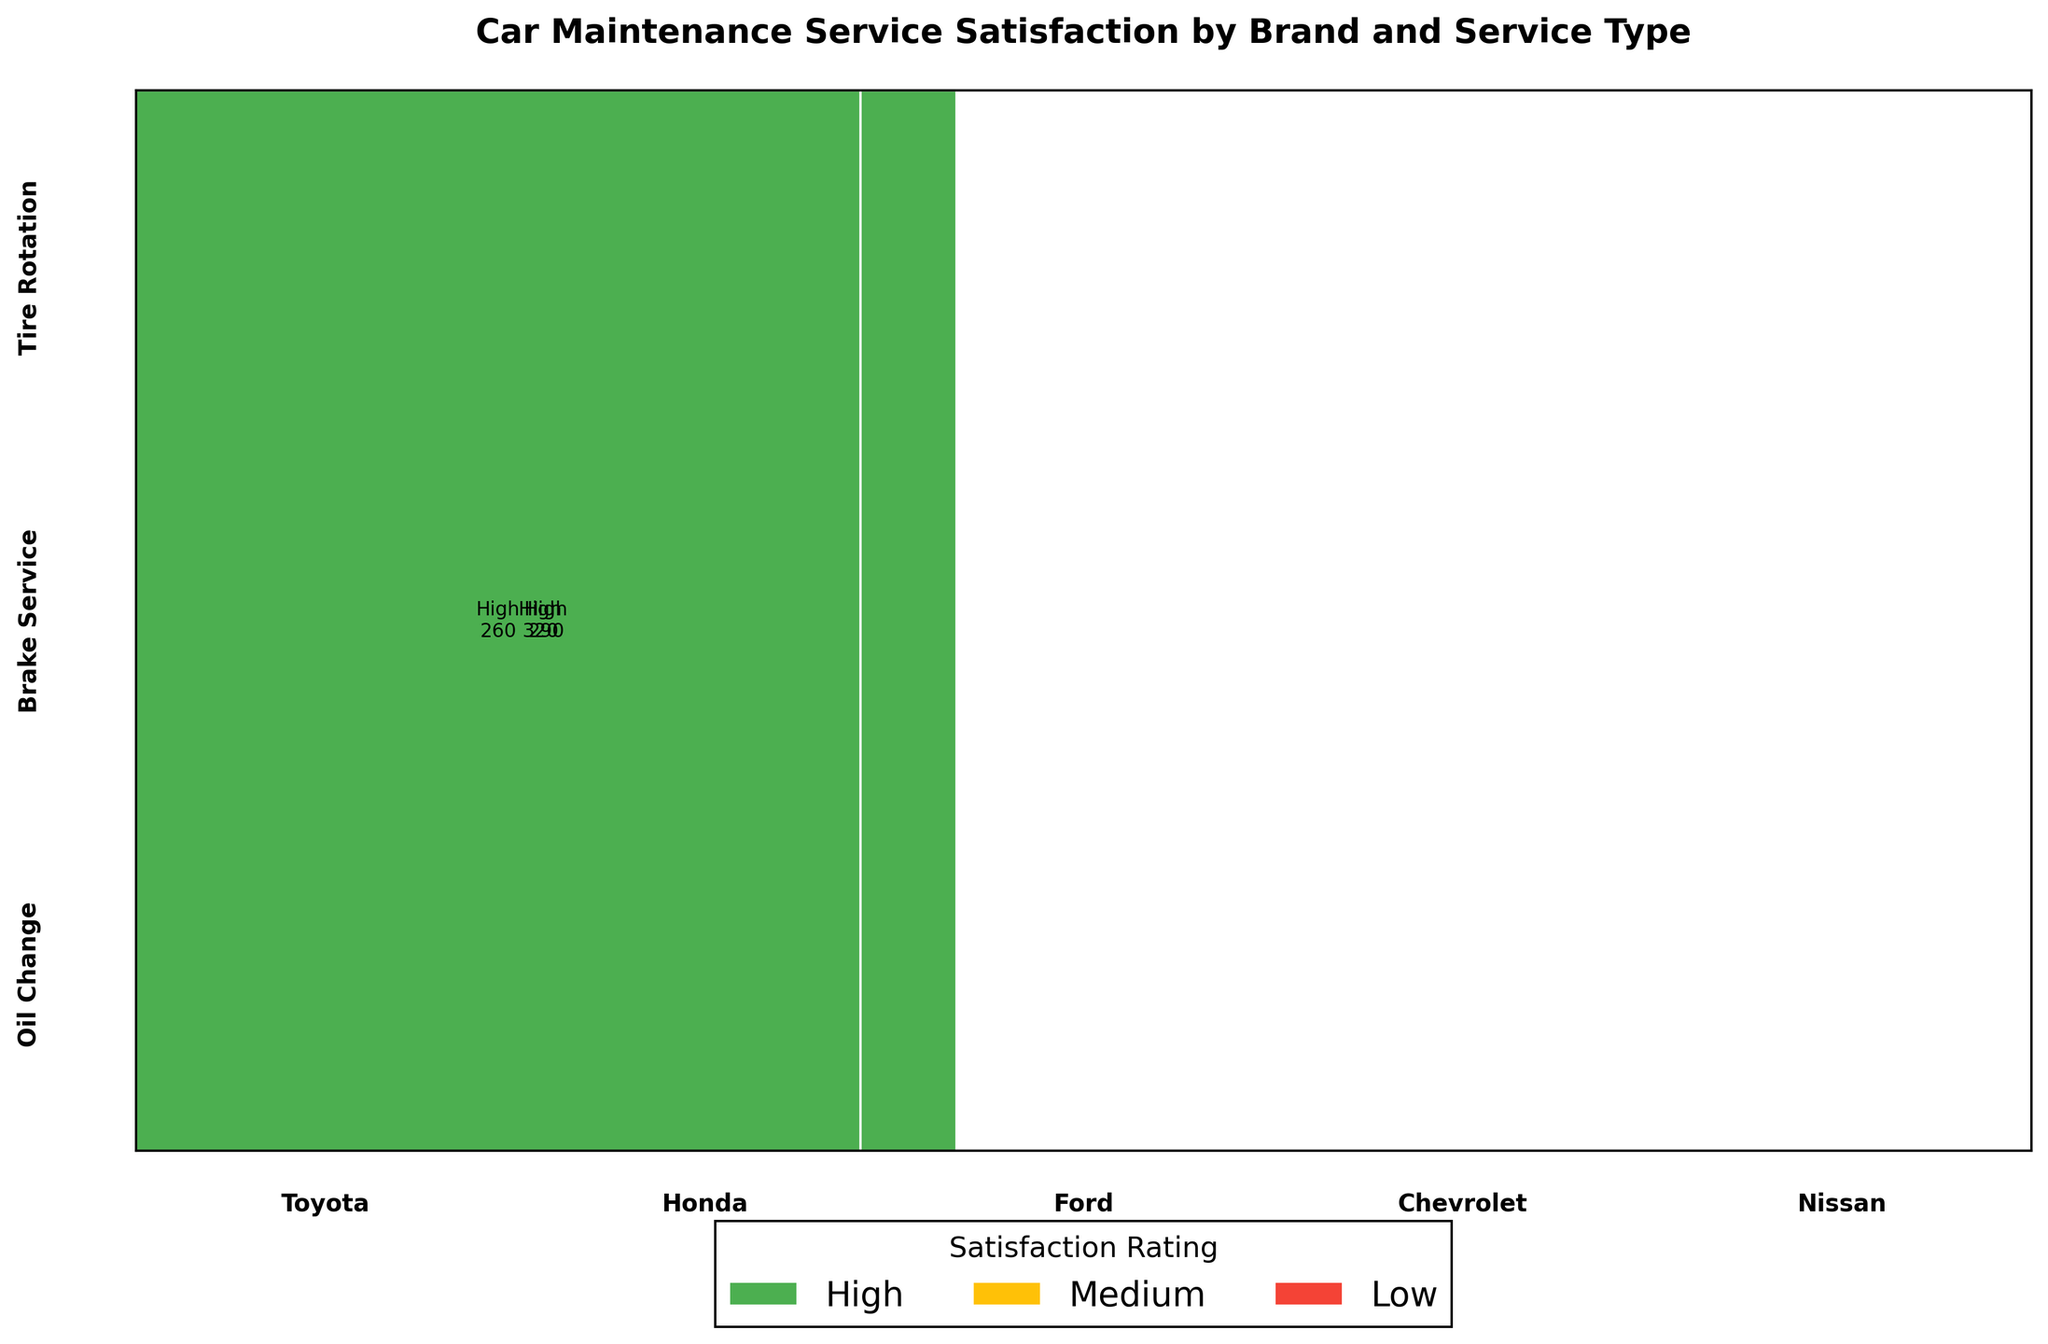What is the title of the plot? The title can be found at the top part of the figure. It summarizes what the plot represents.
Answer: Car Maintenance Service Satisfaction by Brand and Service Type Which vehicle brand has the most 'High' satisfaction ratings for brake service? To determine this, look for 'Brake Service' and then observe which brand has the largest portion in the color representing 'High' satisfaction.
Answer: Honda What is the satisfaction rating for most Toyota tire rotations? Check the section for 'Toyota' under 'Tire Rotation' and see which satisfaction rating (color) has the largest area.
Answer: High How many satisfaction categories are there in the plot? Count the distinct satisfaction ratings represented by different colors in the legend.
Answer: 3 Which service type has the highest 'Medium' satisfaction rating for Ford? Look at the sections under 'Ford' and observe which service type has the largest portion colored in 'Medium'.
Answer: Oil Change For Chevrolet, compare the satisfaction ratings between 'Oil Change' and 'Brake Service'. Which has the higher satisfaction? Check the sections for 'Chevrolet' under 'Oil Change' and 'Brake Service' respectively and compare the proportion of 'High' satisfaction ratings in each.
Answer: Oil Change Between which brands is the 'Tire Rotation' satisfaction rating most similar? Observe the sections for 'Tire Rotation' and identify which brands have similar distributions of satisfaction ratings.
Answer: Nissan and Ford What percentage of Nissan's brake services resulted in 'Low' satisfaction? First, identify the size of the 'Low' satisfaction section under 'Nissan' Brake Service, then divide by the total for 'Nissan' Brake Service and multiply by 100.
Answer: 100 * (130 / (130 + 0 + 0)) = 100% Which vehicle brand has the least 'Low' satisfaction ratings overall? Scan through all sections and find the brand with the smallest area covered by the 'Low' satisfaction rating color.
Answer: Toyota 